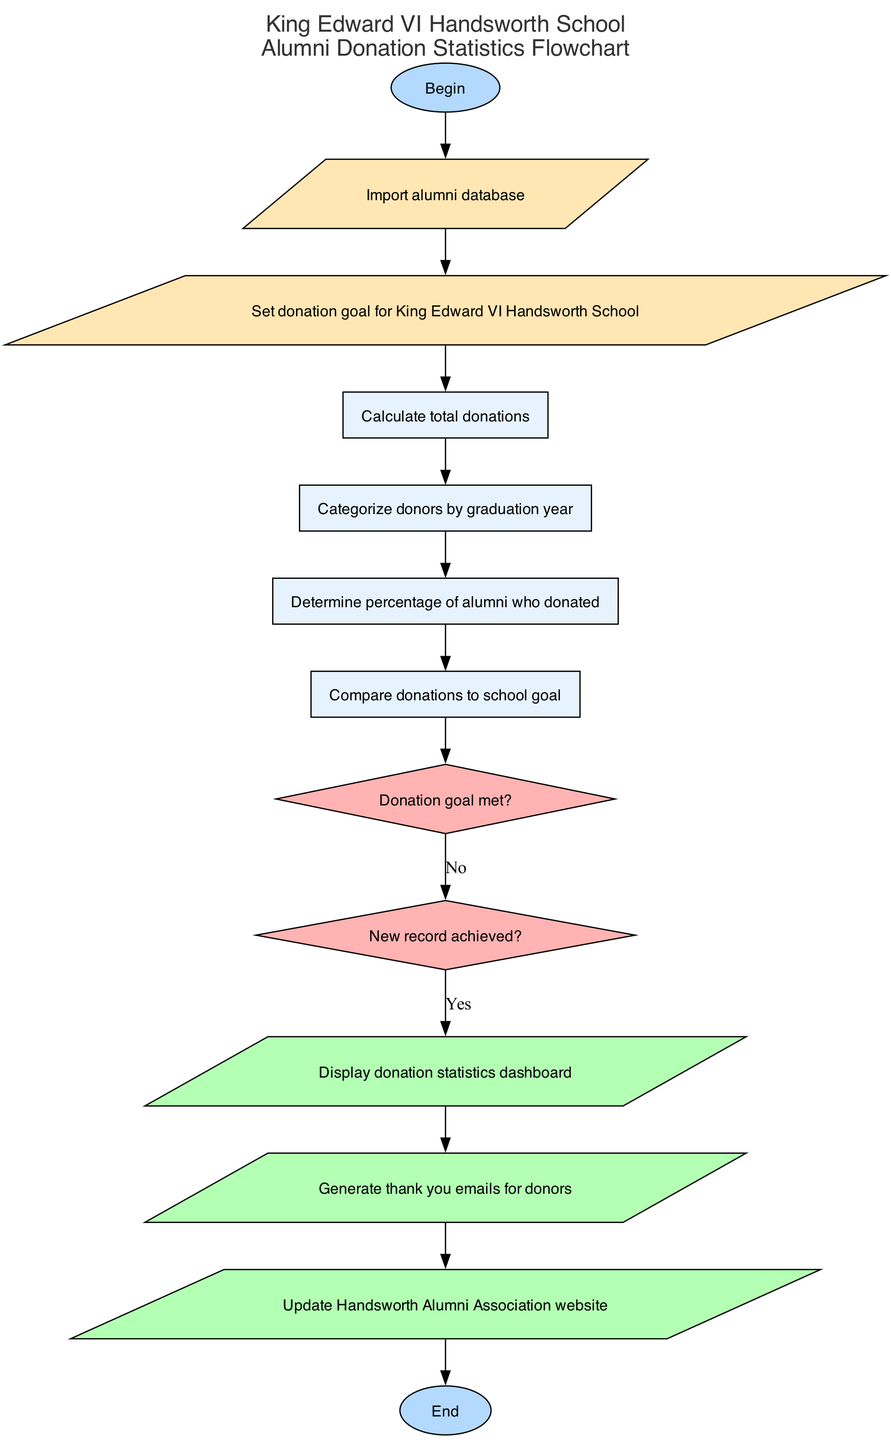What is the first step in the flowchart? The first step in the flowchart is labeled "Begin", which indicates the starting point of the process.
Answer: Begin How many input nodes are there in the flowchart? There are two input nodes, which are described in the inputs section of the diagram.
Answer: 2 What follows after calculating total donations? After calculating total donations, the next step is to categorize donors by graduation year, connecting the two processes in the flow.
Answer: Categorize donors by graduation year What are the outputs of the flowchart? The outputs include three distinct actions that result from the preceding process steps: display donation statistics dashboard, generate thank you emails for donors, and update Handsworth Alumni Association website.
Answer: Display donation statistics dashboard, generate thank you emails for donors, update Handsworth Alumni Association website Which decision node comes after determining the percentage of alumni who donated? The decision node following the determination of the percentage of alumni who donated is "Donation goal met?", indicating a decision point in the process flow.
Answer: Donation goal met? If the donation goal is met, what is the next output? If the donation goal is met, the next output would follow from the "Yes" edge of the decision, leading to "Display donation statistics dashboard", which conveys that the statistics are shown to the relevant parties.
Answer: Display donation statistics dashboard How many processes are there in total? There are four processes listed in the diagram that are crucial to the operation of the algorithm for calculating and displaying alumni donation statistics.
Answer: 4 What color represents the decision nodes in the flowchart? The decision nodes in the flowchart are represented by a diamond shape filled with the color #FFB3B3, distinguishing them from other types of nodes.
Answer: #FFB3B3 Which step is the last process before reaching an output? The last process before reaching an output is "Compare donations to school goal", leading from the process flow into the decision nodes.
Answer: Compare donations to school goal 